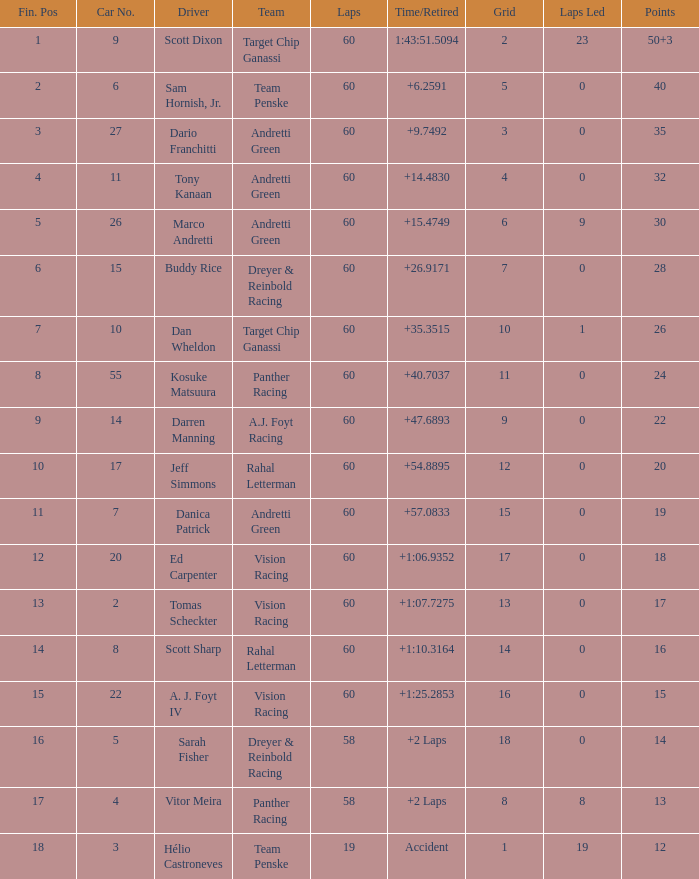Name the team for scott dixon Target Chip Ganassi. 